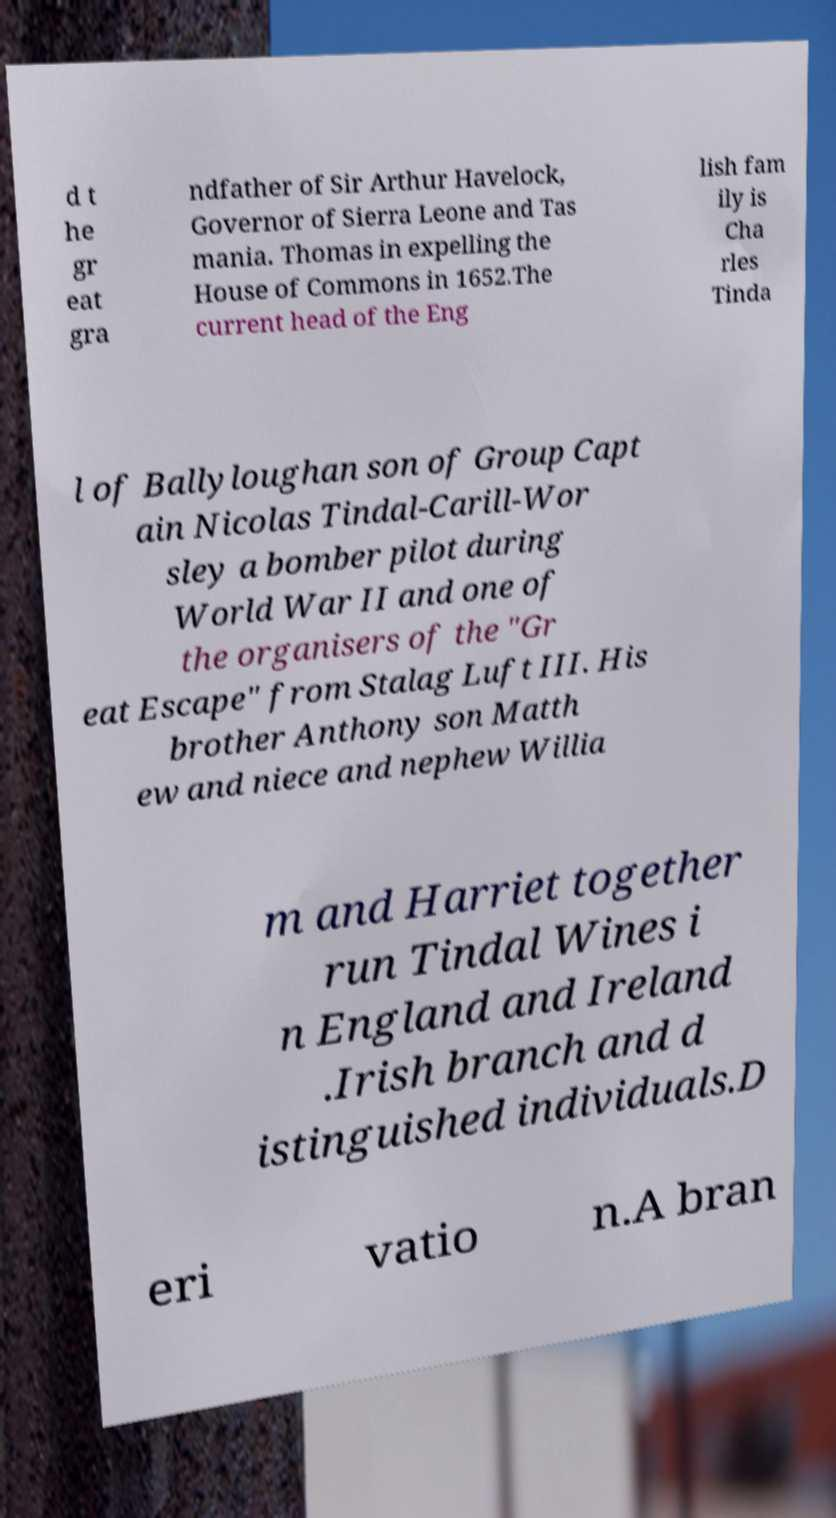For documentation purposes, I need the text within this image transcribed. Could you provide that? d t he gr eat gra ndfather of Sir Arthur Havelock, Governor of Sierra Leone and Tas mania. Thomas in expelling the House of Commons in 1652.The current head of the Eng lish fam ily is Cha rles Tinda l of Ballyloughan son of Group Capt ain Nicolas Tindal-Carill-Wor sley a bomber pilot during World War II and one of the organisers of the "Gr eat Escape" from Stalag Luft III. His brother Anthony son Matth ew and niece and nephew Willia m and Harriet together run Tindal Wines i n England and Ireland .Irish branch and d istinguished individuals.D eri vatio n.A bran 